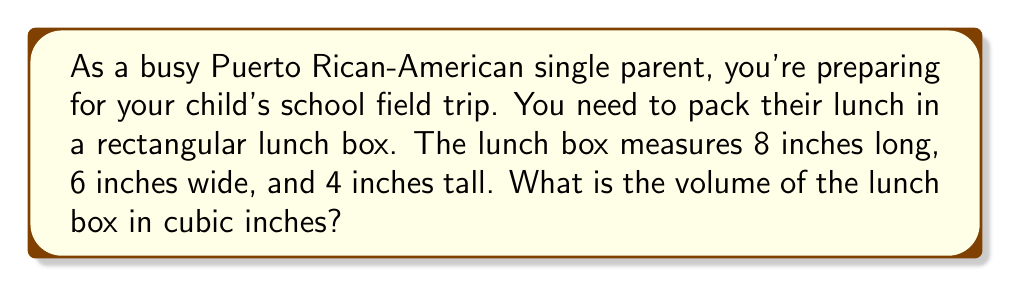Help me with this question. To solve this problem, we need to use the formula for the volume of a rectangular prism:

$$V = l \times w \times h$$

Where:
$V$ = volume
$l$ = length
$w$ = width
$h$ = height

Given dimensions:
Length ($l$) = 8 inches
Width ($w$) = 6 inches
Height ($h$) = 4 inches

Let's substitute these values into the formula:

$$V = 8 \times 6 \times 4$$

Now, let's multiply:

$$V = 48 \times 4 = 192$$

Therefore, the volume of the lunch box is 192 cubic inches.

[asy]
import three;

size(200);
currentprojection=perspective(6,3,2);

draw(box((0,0,0),(8,6,4)));

label("8\"", (4,6,0), S);
label("6\"", (8,3,0), E);
label("4\"", (8,6,2), NE);

draw((8,6,0)--(8,6,4), dashed);
draw((8,0,0)--(8,6,0), dashed);
draw((0,6,0)--(8,6,0), dashed);
[/asy]
Answer: The volume of the lunch box is 192 cubic inches. 